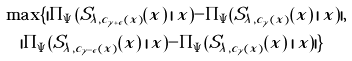<formula> <loc_0><loc_0><loc_500><loc_500>& \max \{ | \Pi _ { \Psi } ( S _ { \lambda , c _ { \gamma + \epsilon } ( x ) } ( x ) \, | \, x ) - \Pi _ { \Psi } ( S _ { \lambda , c _ { \gamma } ( x ) } ( x ) \, | \, x ) | , \\ & \quad | \Pi _ { \Psi } ( S _ { \lambda , c _ { \gamma - \epsilon } ( x ) } ( x ) \, | \, x ) - \Pi _ { \Psi } ( S _ { \lambda , c _ { \gamma } ( x ) } ( x ) \, | \, x ) | \}</formula> 